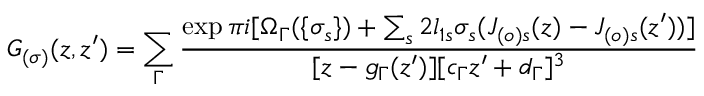<formula> <loc_0><loc_0><loc_500><loc_500>G _ { ( \sigma ) } ( z , z ^ { \prime } ) = \sum _ { \Gamma } \frac { \exp \pi i [ \Omega _ { \Gamma } ( \{ \sigma _ { s } \} ) + \sum _ { s } 2 l _ { 1 s } \sigma _ { s } ( J _ { ( o ) s } ( z ) - J _ { ( o ) s } ( z ^ { \prime } ) ) ] } { [ z - g _ { \Gamma } ( z ^ { \prime } ) ] [ c _ { \Gamma } z ^ { \prime } + d _ { \Gamma } ] ^ { 3 } }</formula> 